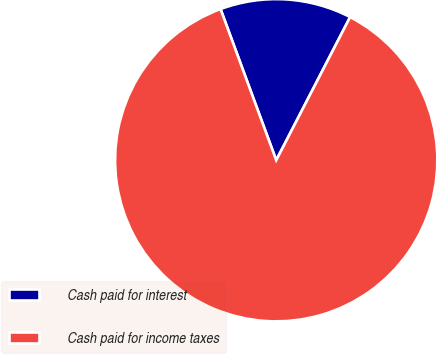Convert chart. <chart><loc_0><loc_0><loc_500><loc_500><pie_chart><fcel>Cash paid for interest<fcel>Cash paid for income taxes<nl><fcel>13.2%<fcel>86.8%<nl></chart> 